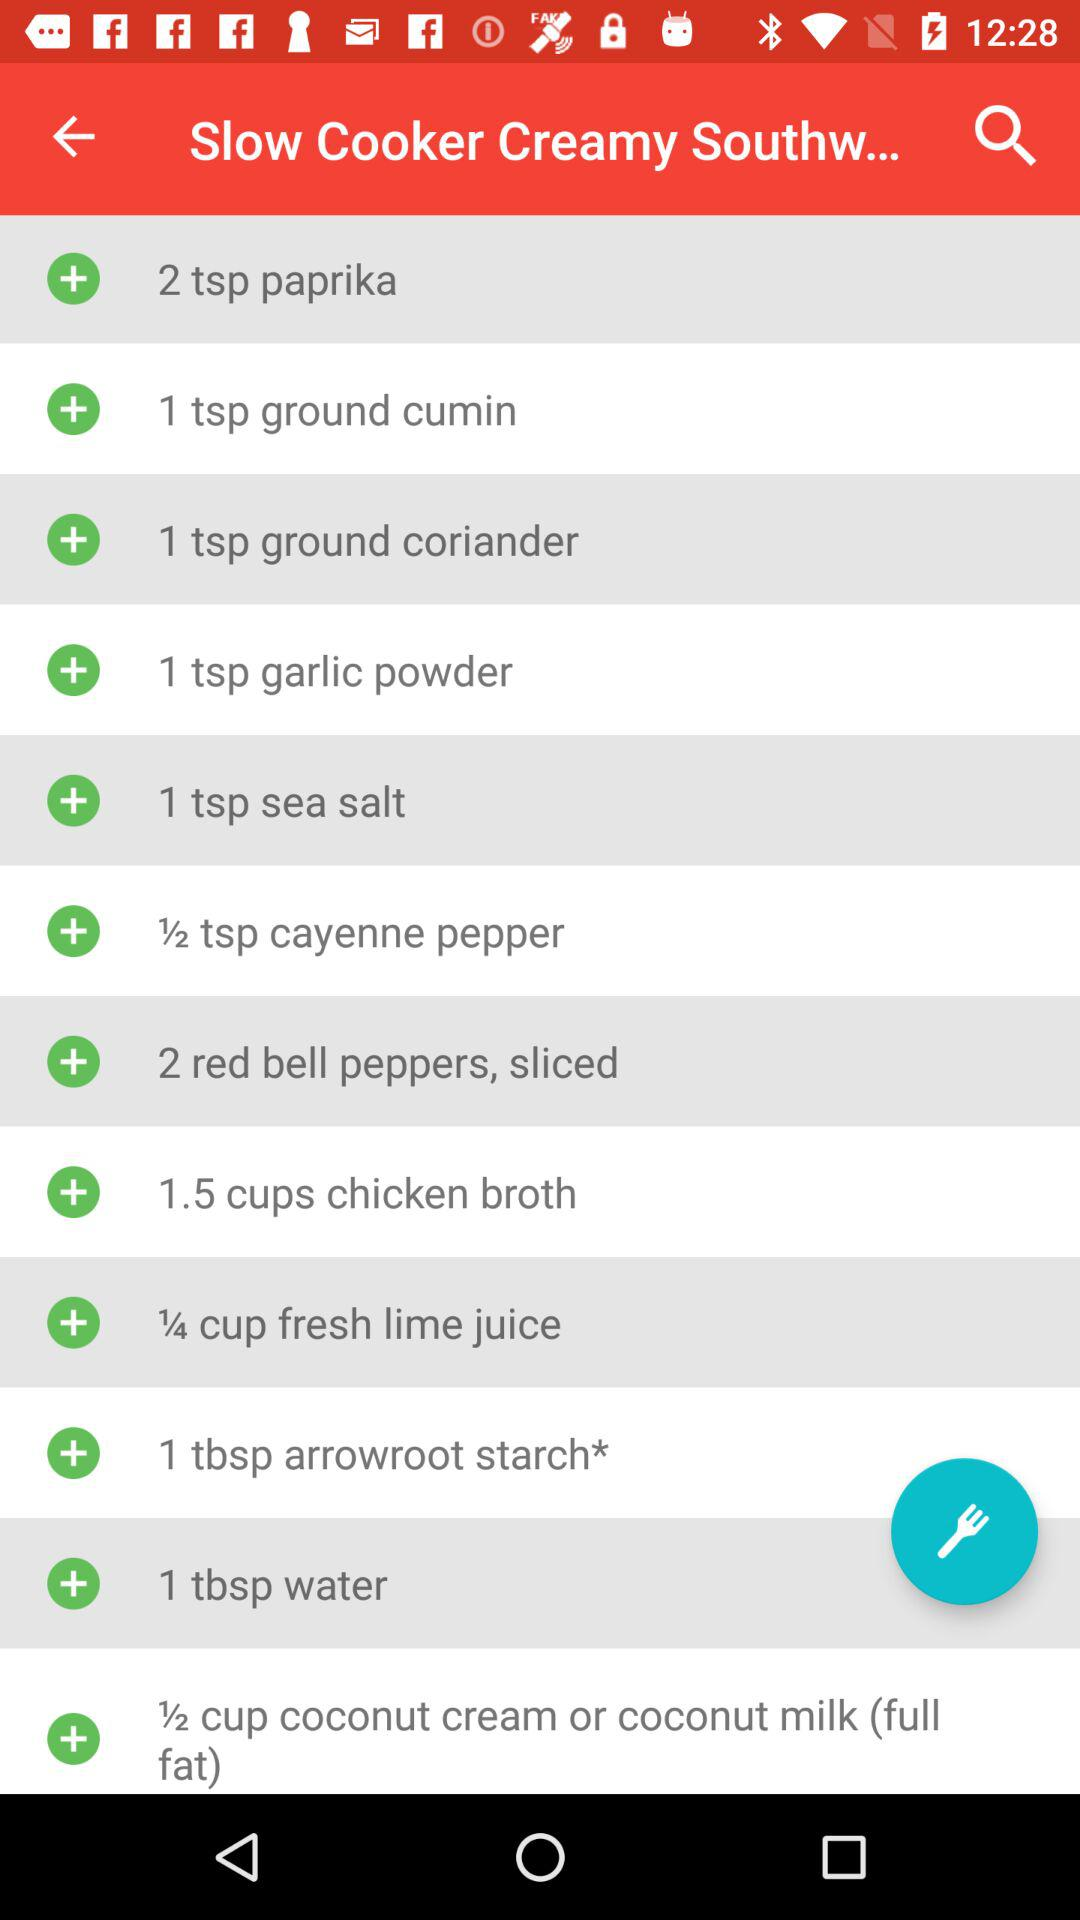How many ingredients do you need to make this recipe?
Answer the question using a single word or phrase. 12 